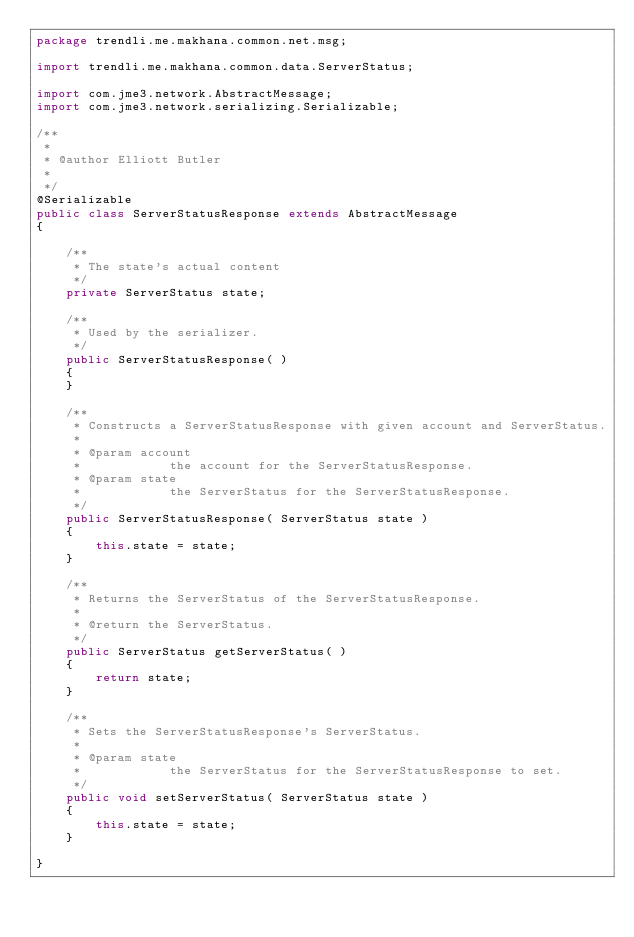Convert code to text. <code><loc_0><loc_0><loc_500><loc_500><_Java_>package trendli.me.makhana.common.net.msg;

import trendli.me.makhana.common.data.ServerStatus;

import com.jme3.network.AbstractMessage;
import com.jme3.network.serializing.Serializable;

/**
 * 
 * @author Elliott Butler
 * 
 */
@Serializable
public class ServerStatusResponse extends AbstractMessage
{

    /**
     * The state's actual content
     */
    private ServerStatus state;

    /**
     * Used by the serializer.
     */
    public ServerStatusResponse( )
    {
    }

    /**
     * Constructs a ServerStatusResponse with given account and ServerStatus.
     * 
     * @param account
     *            the account for the ServerStatusResponse.
     * @param state
     *            the ServerStatus for the ServerStatusResponse.
     */
    public ServerStatusResponse( ServerStatus state )
    {
        this.state = state;
    }

    /**
     * Returns the ServerStatus of the ServerStatusResponse.
     * 
     * @return the ServerStatus.
     */
    public ServerStatus getServerStatus( )
    {
        return state;
    }

    /**
     * Sets the ServerStatusResponse's ServerStatus.
     * 
     * @param state
     *            the ServerStatus for the ServerStatusResponse to set.
     */
    public void setServerStatus( ServerStatus state )
    {
        this.state = state;
    }

}
</code> 